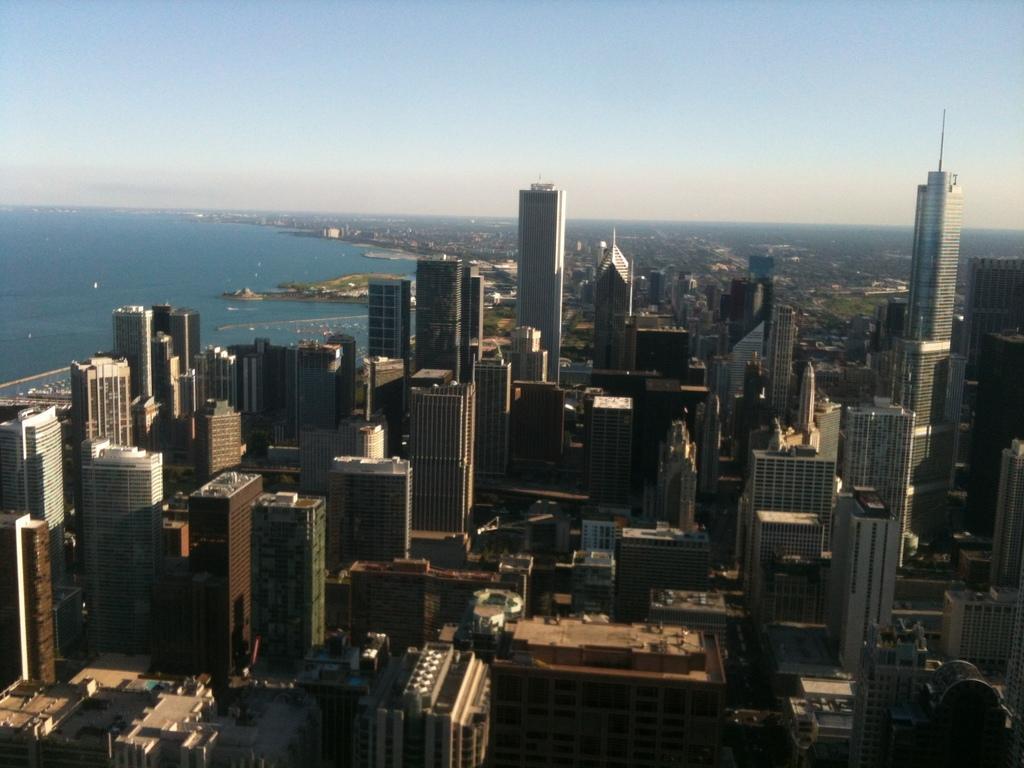Could you give a brief overview of what you see in this image? In this image we can see many buildings. On the left side there is water. In the background there is sky. 